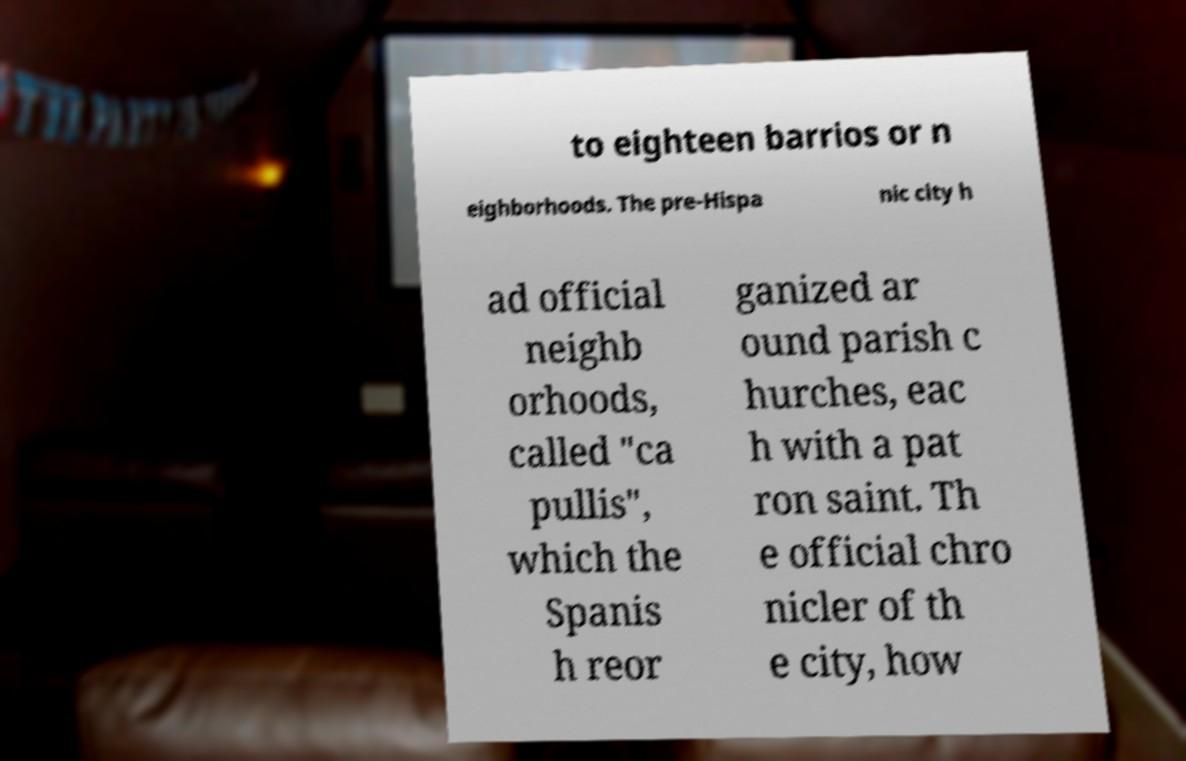Can you accurately transcribe the text from the provided image for me? to eighteen barrios or n eighborhoods. The pre-Hispa nic city h ad official neighb orhoods, called "ca pullis", which the Spanis h reor ganized ar ound parish c hurches, eac h with a pat ron saint. Th e official chro nicler of th e city, how 